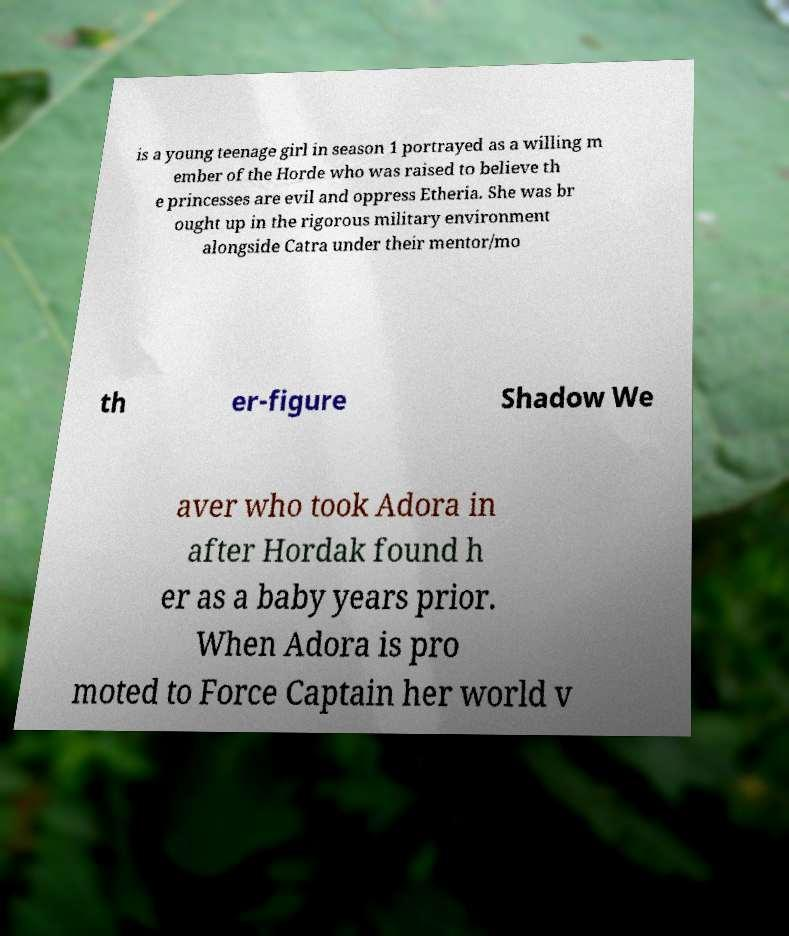I need the written content from this picture converted into text. Can you do that? is a young teenage girl in season 1 portrayed as a willing m ember of the Horde who was raised to believe th e princesses are evil and oppress Etheria. She was br ought up in the rigorous military environment alongside Catra under their mentor/mo th er-figure Shadow We aver who took Adora in after Hordak found h er as a baby years prior. When Adora is pro moted to Force Captain her world v 